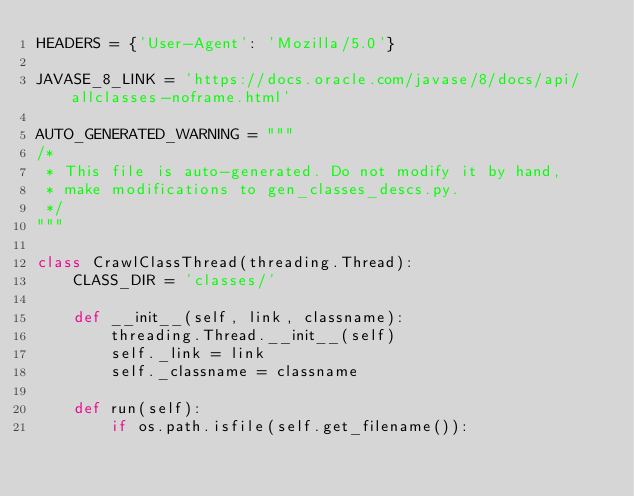<code> <loc_0><loc_0><loc_500><loc_500><_Python_>HEADERS = {'User-Agent': 'Mozilla/5.0'}

JAVASE_8_LINK = 'https://docs.oracle.com/javase/8/docs/api/allclasses-noframe.html'

AUTO_GENERATED_WARNING = """
/*
 * This file is auto-generated. Do not modify it by hand, 
 * make modifications to gen_classes_descs.py.
 */
"""

class CrawlClassThread(threading.Thread):
    CLASS_DIR = 'classes/'

    def __init__(self, link, classname):
        threading.Thread.__init__(self)
        self._link = link
        self._classname = classname
   
    def run(self):
        if os.path.isfile(self.get_filename()):</code> 